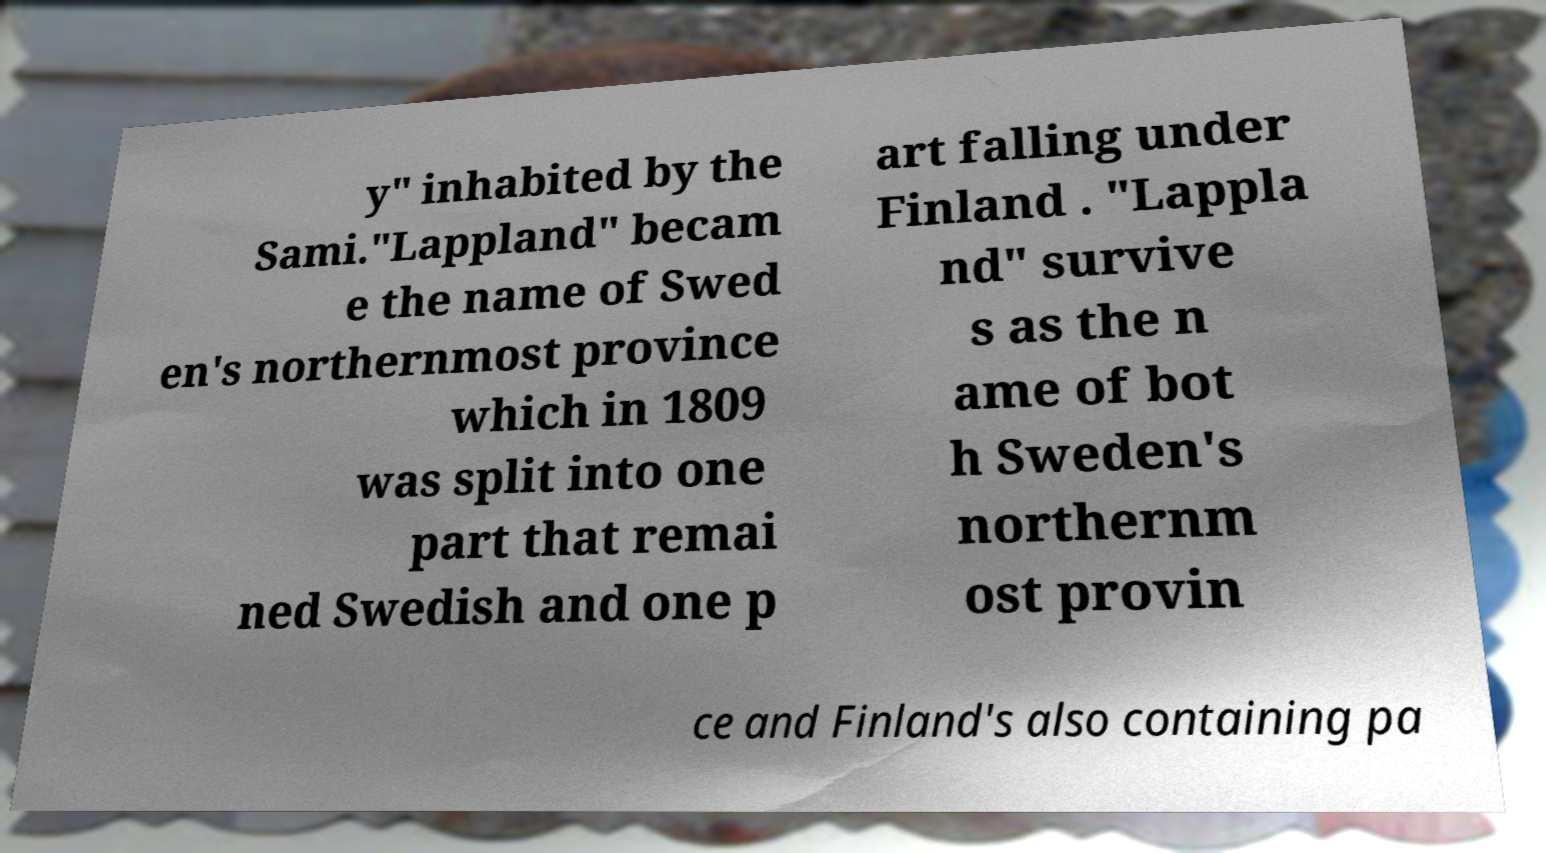For documentation purposes, I need the text within this image transcribed. Could you provide that? y" inhabited by the Sami."Lappland" becam e the name of Swed en's northernmost province which in 1809 was split into one part that remai ned Swedish and one p art falling under Finland . "Lappla nd" survive s as the n ame of bot h Sweden's northernm ost provin ce and Finland's also containing pa 